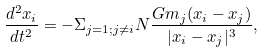<formula> <loc_0><loc_0><loc_500><loc_500>\frac { d ^ { 2 } x _ { i } } { d t ^ { 2 } } = - \Sigma _ { j = 1 ; j \neq i } { N } \frac { G m _ { j } ( x _ { i } - x _ { j } ) } { | x _ { i } - x _ { j } | ^ { 3 } } ,</formula> 